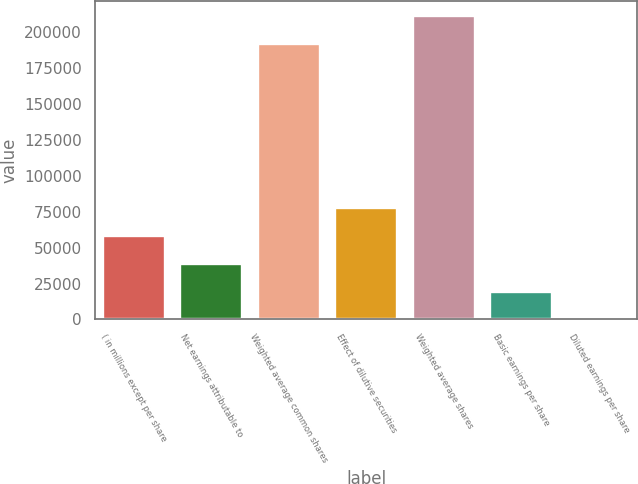Convert chart. <chart><loc_0><loc_0><loc_500><loc_500><bar_chart><fcel>( in millions except per share<fcel>Net earnings attributable to<fcel>Weighted average common shares<fcel>Effect of dilutive securities<fcel>Weighted average shares<fcel>Basic earnings per share<fcel>Diluted earnings per share<nl><fcel>58212.6<fcel>38808.9<fcel>191714<fcel>77616.2<fcel>211118<fcel>19405.3<fcel>1.65<nl></chart> 